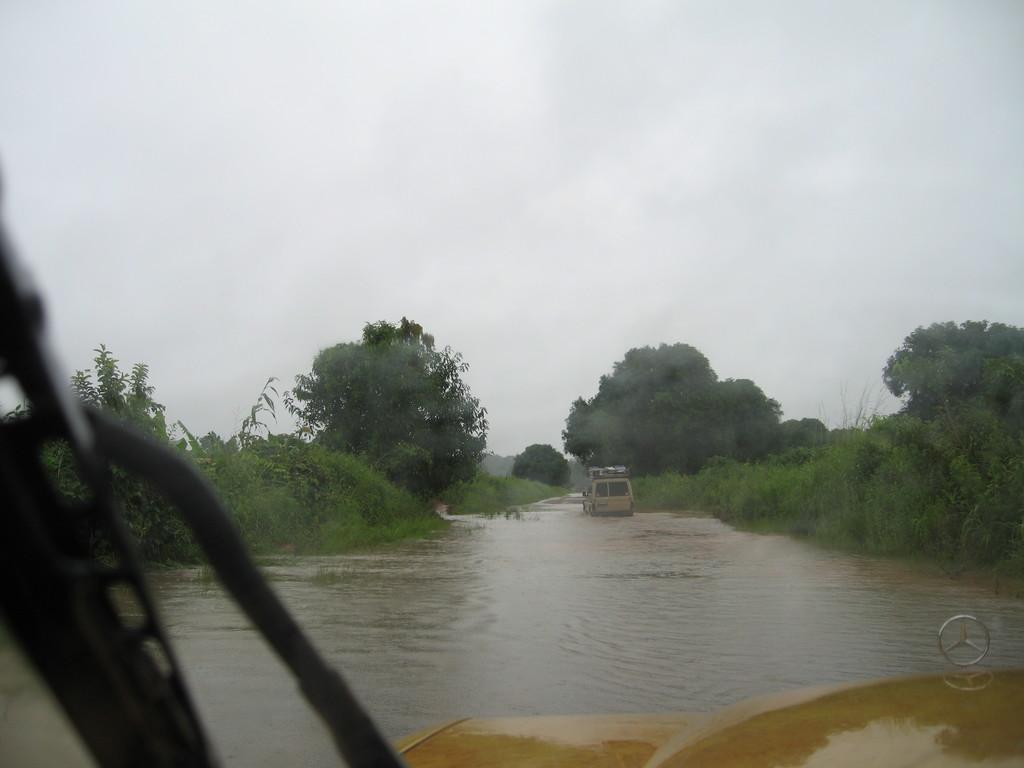What type of vehicles can be seen in the water in the image? There are vehicles in the water in the image. What type of vegetation is visible in the image? There are trees visible in the image. What can be seen in the background of the image? The sky is visible in the background of the image. What type of potato is being used to make the beef dish in the image? There is no potato or beef dish present in the image. Can you see a ring on anyone's finger in the image? There is no ring or person visible in the image. 